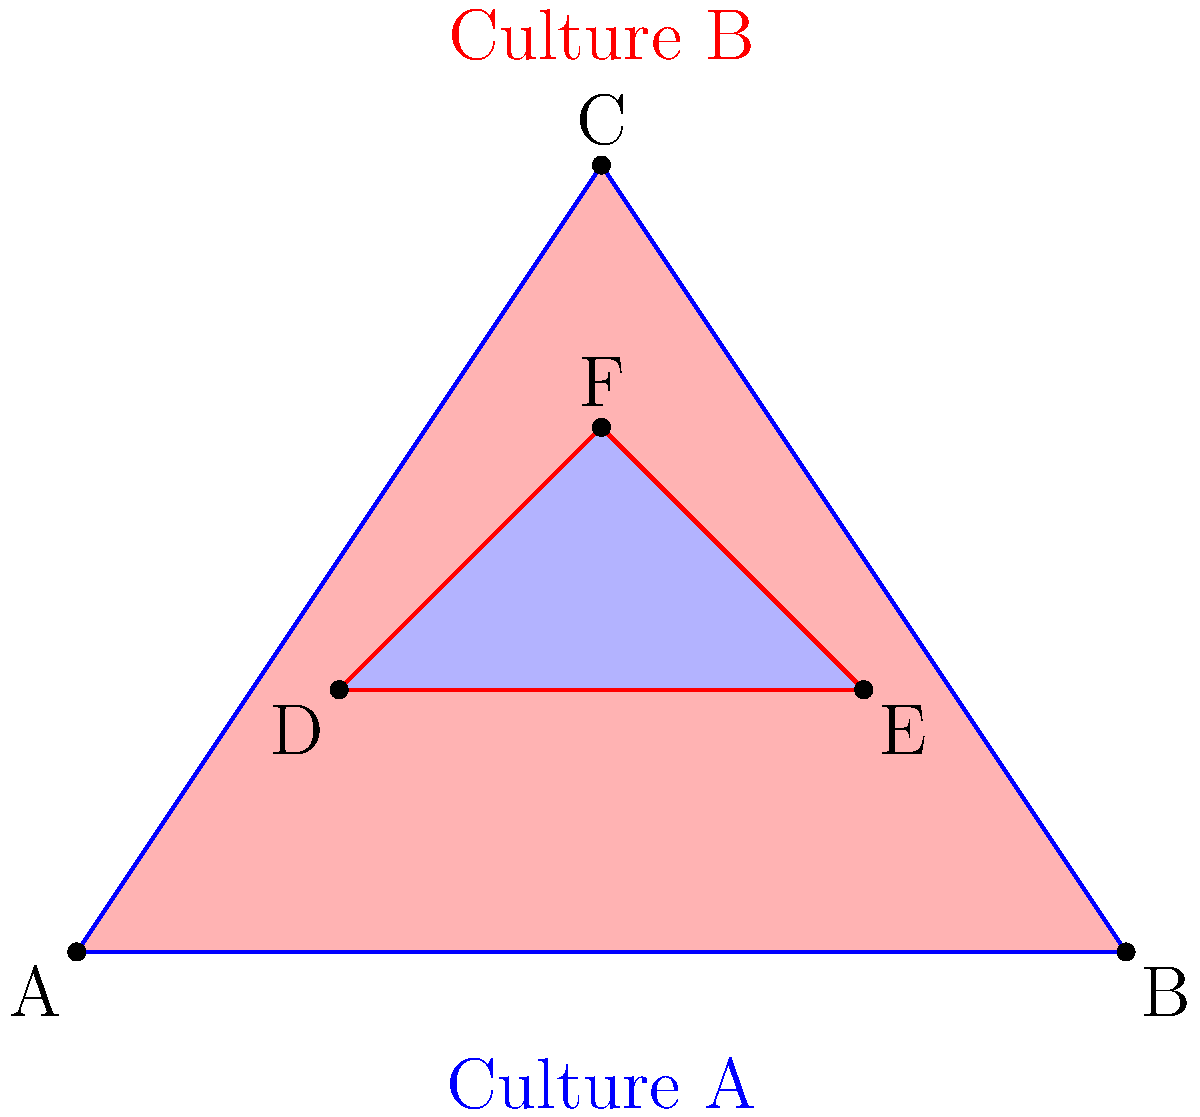In a study of cultural influence, two overlapping zones are represented by triangles. Triangle ABC represents Culture A's influence, while triangle DEF represents Culture B's influence. Given that the area of triangle ABC is 6 square units and the area of triangle DEF is 2 square units, what fraction of the total area of both cultures is represented by their overlapping region? How might this overlap relate to personality factors in diplomatic interactions between these cultures? To solve this problem, we need to follow these steps:

1. Calculate the total area of both triangles:
   Total area = Area of ABC + Area of DEF = 6 + 2 = 8 square units

2. Calculate the area of the overlapping region:
   Let's call the overlapping region O.
   Area of O = Area of ABC + Area of DEF - Area of (ABC ∪ DEF)
   
   We don't know the exact area of (ABC ∪ DEF), but we can express it in terms of O:
   Area of (ABC ∪ DEF) = Area of ABC + Area of DEF - Area of O
   
   Therefore:
   Area of O = 6 + 2 - (6 + 2 - Area of O)
   Area of O = 8 - (8 - Area of O)
   2 * Area of O = 8
   Area of O = 4 square units

3. Calculate the fraction of the overlapping region:
   Fraction = Area of O / Total area = 4 / 8 = 1/2

Relating to personality factors in diplomacy:
The significant overlap (half of the total area) suggests a large shared cultural space between the two cultures. This overlap could represent:

1. Common values or beliefs that might serve as a foundation for diplomatic negotiations.
2. Shared historical experiences that shape personality traits valued in both cultures.
3. Similar communication styles or social norms that could facilitate understanding.

From a personality-focused perspective in diplomacy, this overlap might indicate:

1. A higher likelihood of finding diplomats with personality traits that resonate well with both cultures.
2. Potential for smoother negotiations due to shared personality-based expectations in social interactions.
3. Opportunities for leveraging common personality traits to build trust and rapport in diplomatic relations.

However, it's crucial to note that while this overlap suggests potential for understanding, the non-overlapping areas (also half of the total) represent unique aspects of each culture. Successful diplomacy would involve navigating both the shared and distinct personality factors of each culture.
Answer: 1/2 of the total area; large overlap suggests potential for shared personality traits facilitating diplomacy, but unique cultural aspects remain significant. 